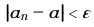Convert formula to latex. <formula><loc_0><loc_0><loc_500><loc_500>\left | a _ { n } - a \right | < \varepsilon</formula> 